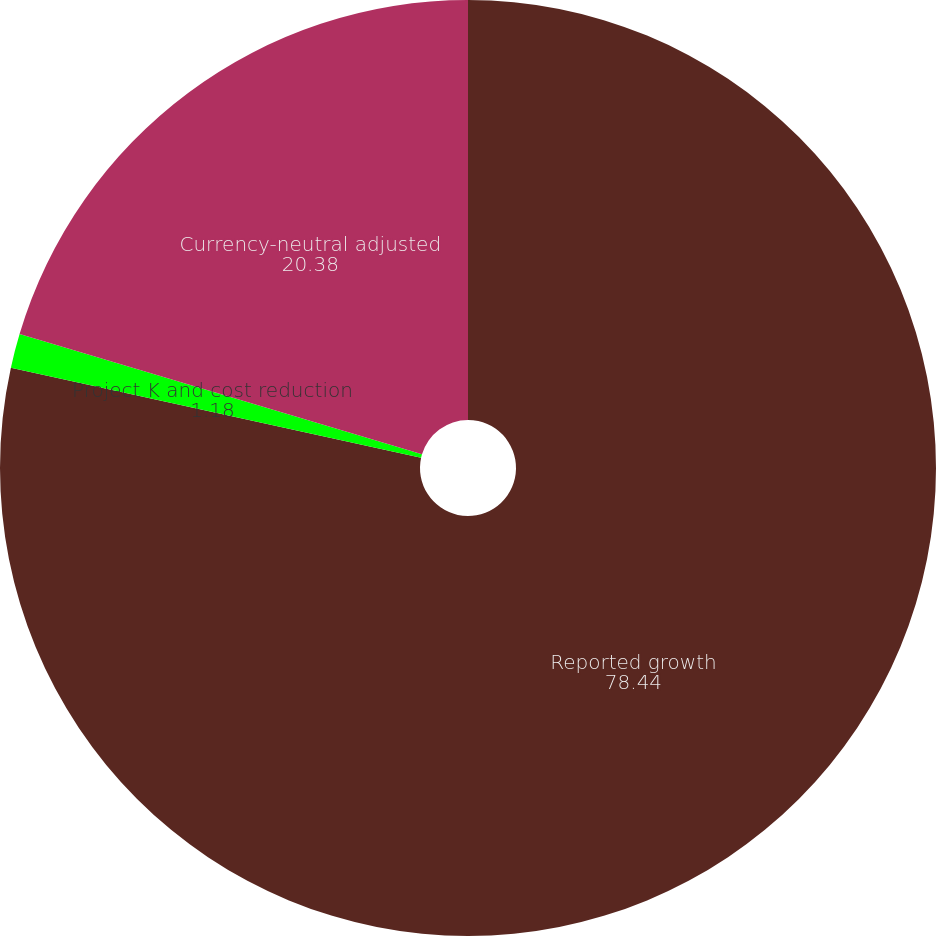Convert chart. <chart><loc_0><loc_0><loc_500><loc_500><pie_chart><fcel>Reported growth<fcel>Project K and cost reduction<fcel>Currency-neutral adjusted<nl><fcel>78.44%<fcel>1.18%<fcel>20.38%<nl></chart> 